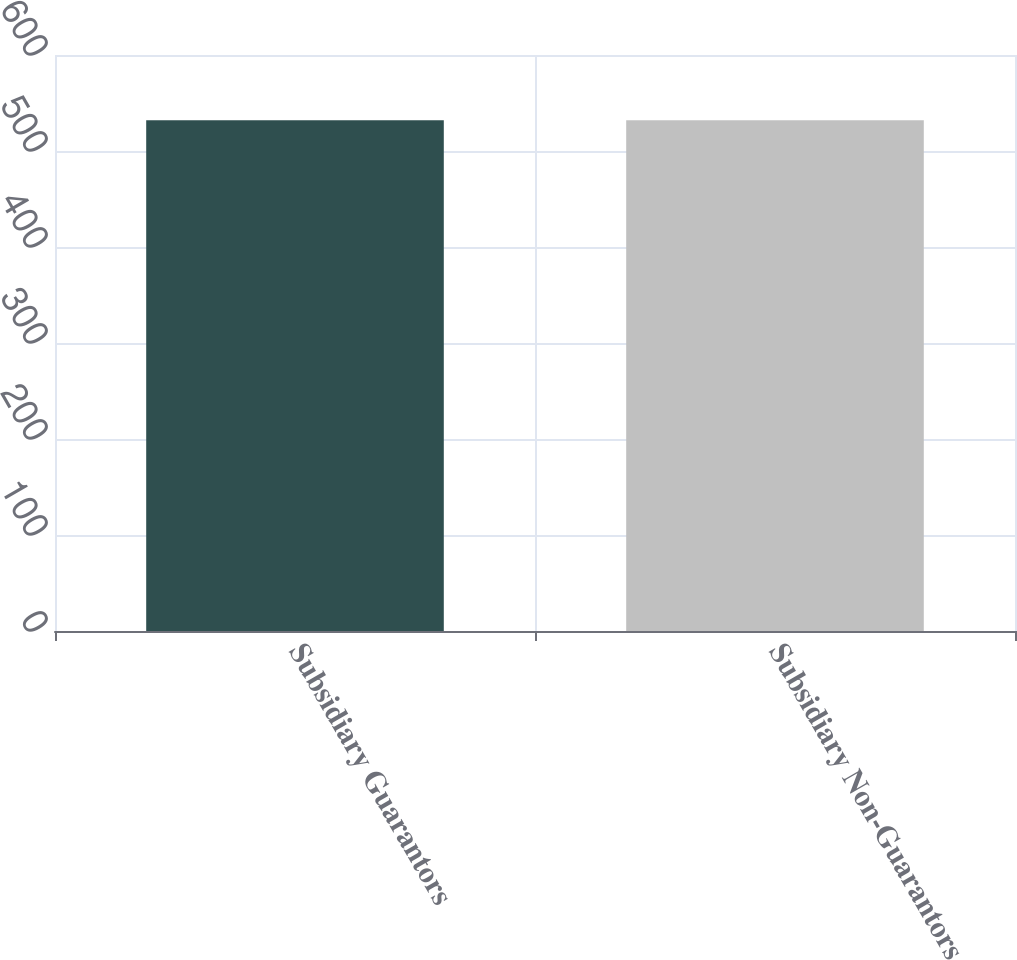Convert chart to OTSL. <chart><loc_0><loc_0><loc_500><loc_500><bar_chart><fcel>Subsidiary Guarantors<fcel>Subsidiary Non-Guarantors<nl><fcel>532<fcel>532.1<nl></chart> 